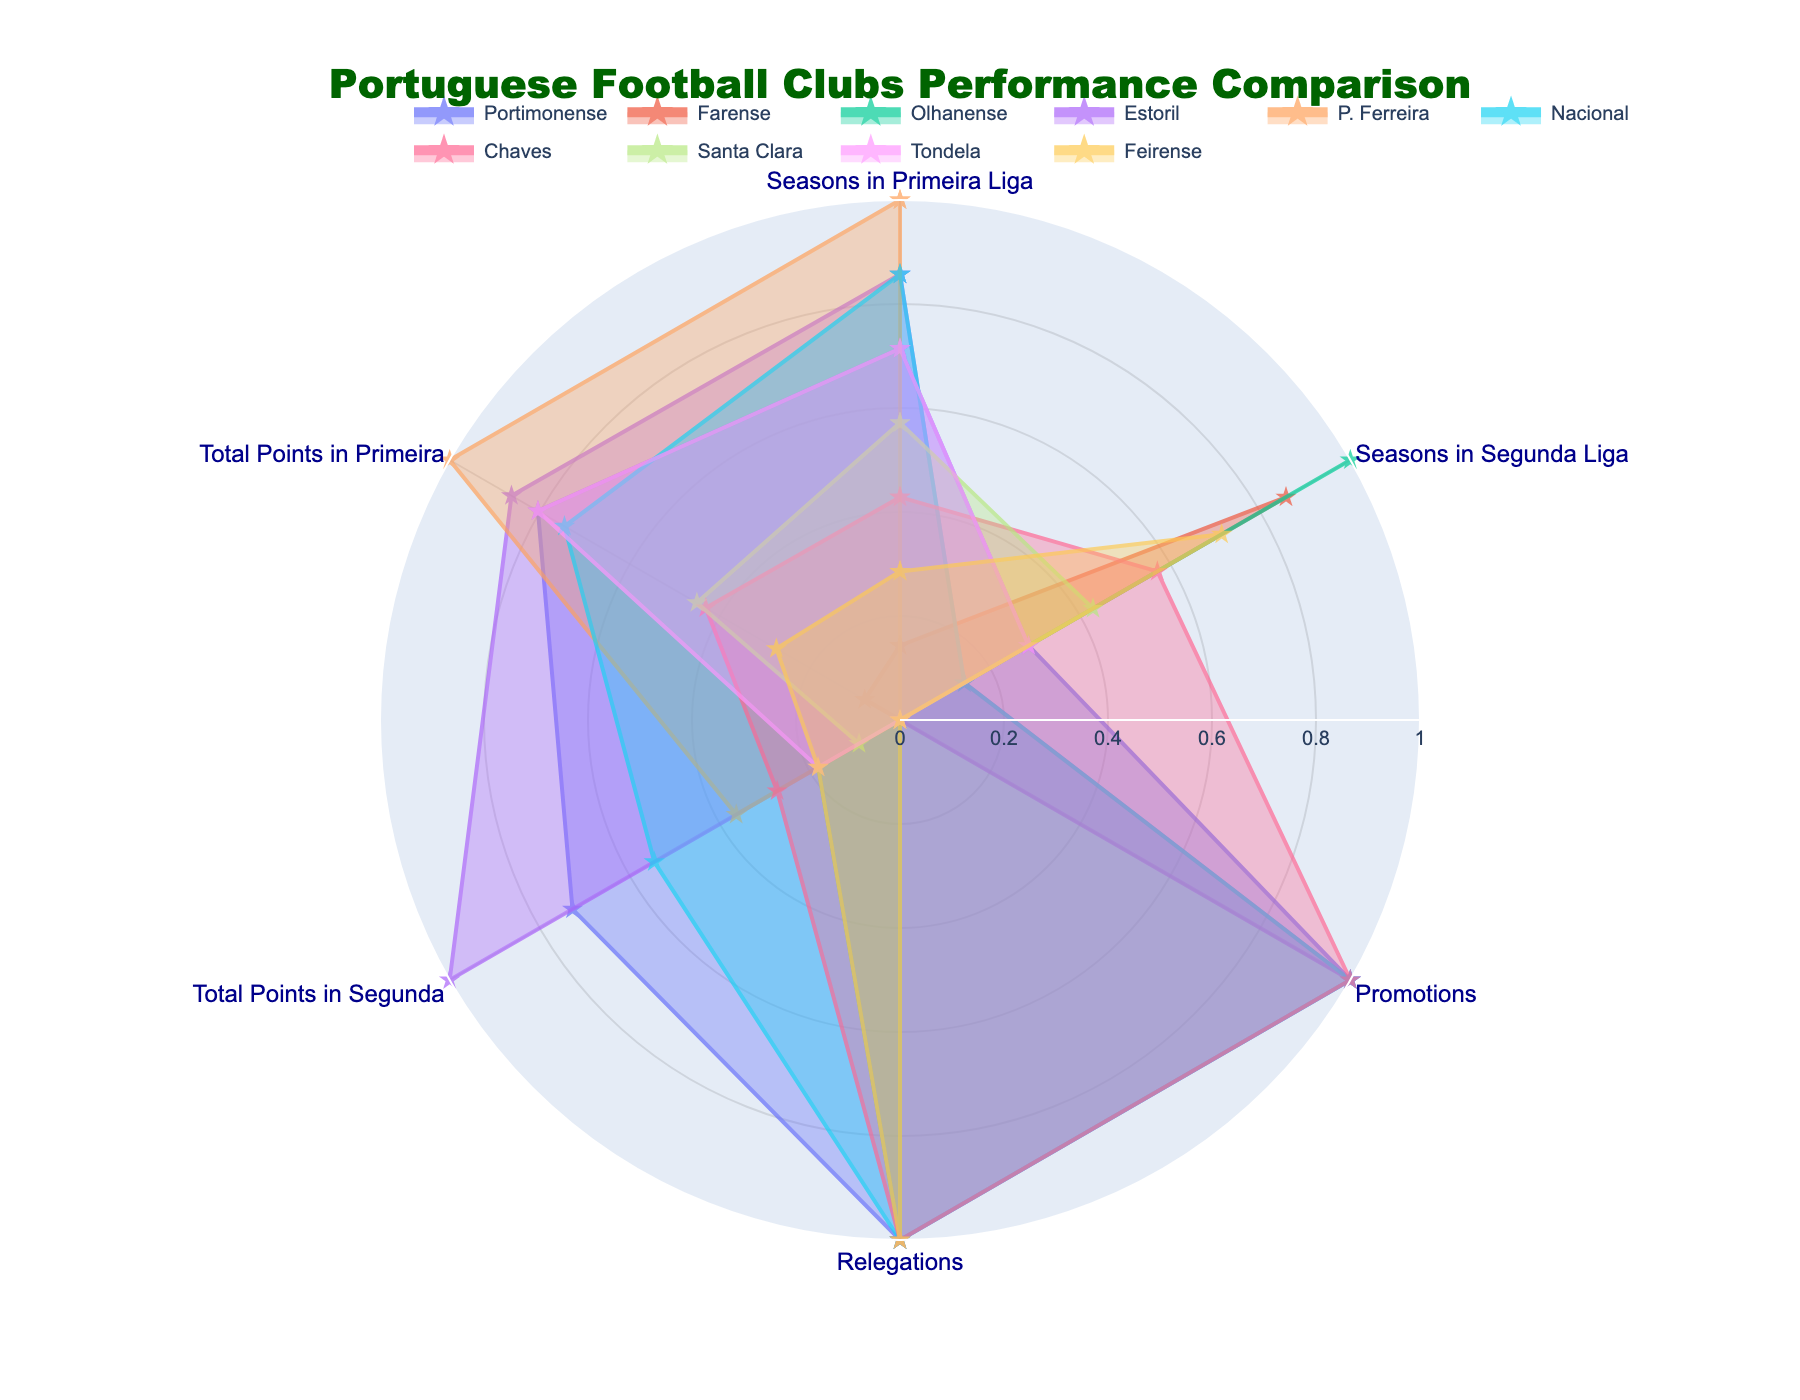What does the radar chart's title say? The title is prominently displayed at the top of the radar chart and provides a brief summary of what the chart represents. In this case, one would look at the top section of the chart and read the text there.
Answer: Portuguese Football Clubs Performance Comparison Which club has the highest normalized value in "Seasons in Primeira Liga"? By observing the radar chart, you can look at the category labeled "Seasons in Primeira Liga" and identify which club's radar plot extends the farthest in that direction.
Answer: P. Ferreira How does Portimonense's normalized value for "Total Points in Primeira" compare to Estoril's? Identify the sections of the radar chart corresponding to "Total Points in Primeira" for both Portimonense and Estoril, then compare their extensions to see which is greater.
Answer: Estoril's value is higher Which club has the most balanced performance across all categories? Look for the radar plot that forms the most regular and evenly spread shape, indicating a balanced performance across all categories.
Answer: Estoril How many clubs have higher normalized values for "Relegations" than "Promotions"? Count the number of clubs whose radar chart extends further in the direction of "Relegations" compared to "Promotions."
Answer: Three clubs Which club has the least normalized value on "Total Points in Segunda" and how do other clubs compare with it? Check which club's radar plot is shortest in the "Total Points in Segunda" direction and then compare the distances of other clubs' plots in this direction.
Answer: Farense has the least; most other clubs have higher values Which club shows a greater difference between "Seasons in Segunda Liga" and "Seasons in Primeira Liga"? Look at the radar segments for both "Seasons in Segunda Liga" and "Seasons in Primeira Liga" for each club to identify which club has the largest distance between these two points.
Answer: Farense Which two clubs have the closest performance in terms of normalized values across all categories? Identify the club pairs whose radar plots overlap the most or follow a similar pattern across all categories.
Answer: P. Ferreira and Estoril What is the overall trend you observe among clubs that have had more than 5 seasons in Primeira Liga? Infer a trend by examining the normalized values in the category "Seasons in Primeira Liga" for clubs with values to the right of the midpoint and identifying any common patterns across other categories.
Answer: They tend to have higher normalized values in "Total Points in Primeira" For the club with the highest normalized value in "Promotions," what is its normalized value for "Relegations"? Find the club with the highest radar plot extension in "Promotions" and then check the length of that same club's plot in the "Relegations" direction.
Answer: Low (Nacional has the highest in Promotions and a higher Relegations) 